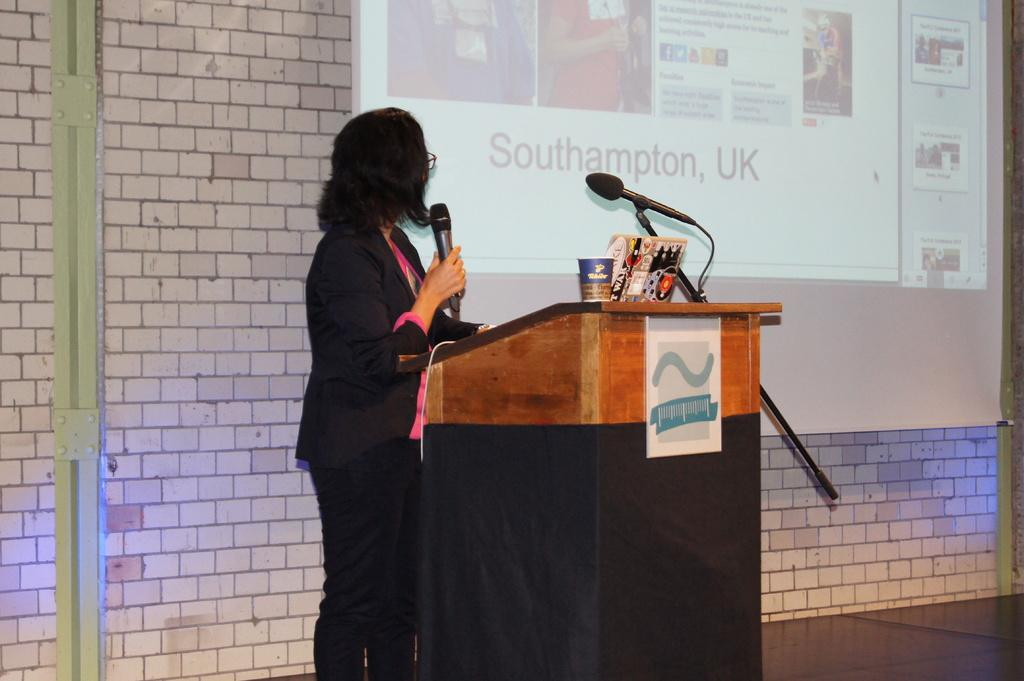Who is present in the image? There is a woman in the image. What is the woman doing in the image? The woman is standing on the floor and holding a microphone. What type of wall can be seen in the image? There is a wall made of bricks in the image. What device is visible in the image? There is a projector in the image. What type of stitch is the woman using to sew a shirt in the image? There is no sewing or shirt present in the image; the woman is holding a microphone and standing near a brick wall and a projector. 